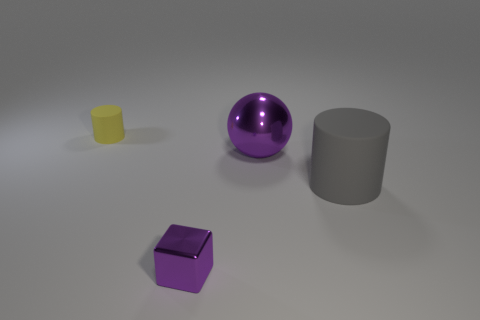Is the material of the yellow thing the same as the purple block? no 